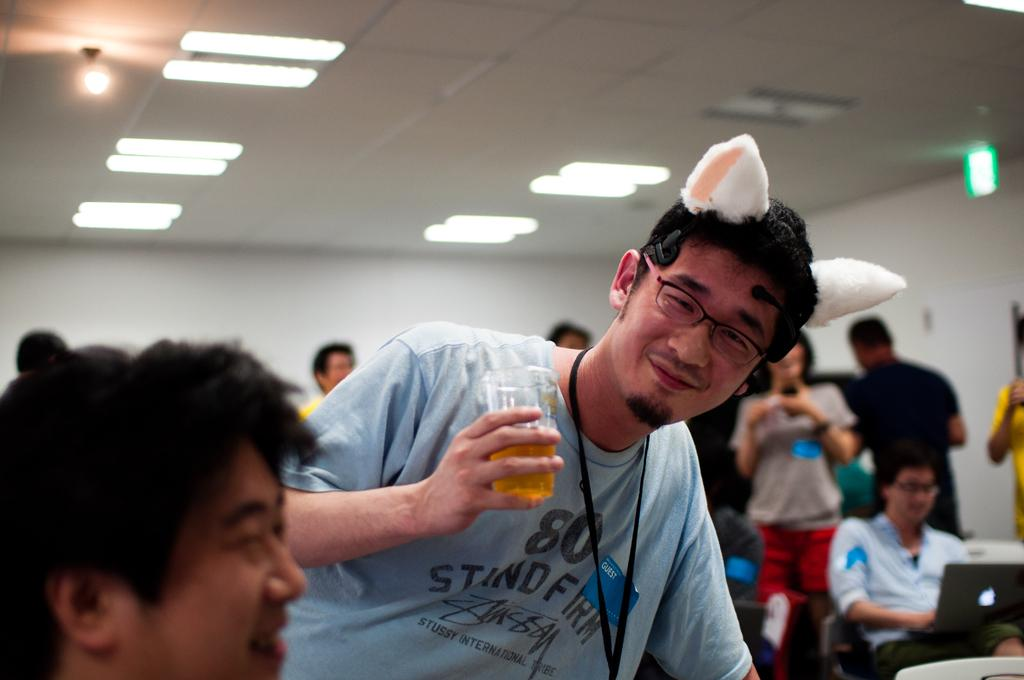What is the man in the image holding? The man is holding a glass in the image. What are the people in the image doing? There are people sitting in the image. What electronic device can be seen in the image? A laptop is visible in the image. What is in the background of the image? There is a wall in the background of the image. What is at the top of the image? There are lights at the top of the image. How does the bee navigate through the rainstorm in the image? There is no bee or rainstorm present in the image. What type of shoes are the people wearing in the image? The provided facts do not mention any shoes, so we cannot determine what type of shoes the people are wearing in the image. 